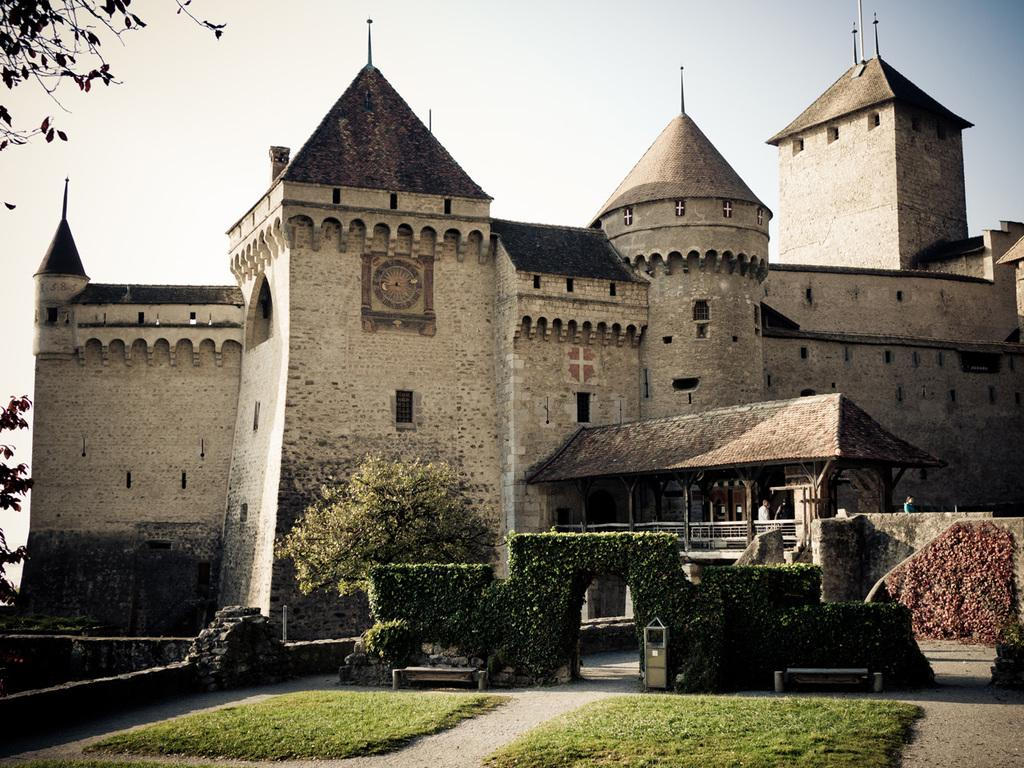What type of ground is visible in the image? There is a greenery ground in the image. What else can be seen growing on the ground? There are plants in the image. Are there any people present in the image? Yes, there are people in the image. What type of structure is visible in the image? There is: There is a building in the image. Where are the trees located in the image? The trees are in the left corner of the image. What is the purpose of the ice in the image? There is no ice present in the image, so it is not possible to determine its purpose. 